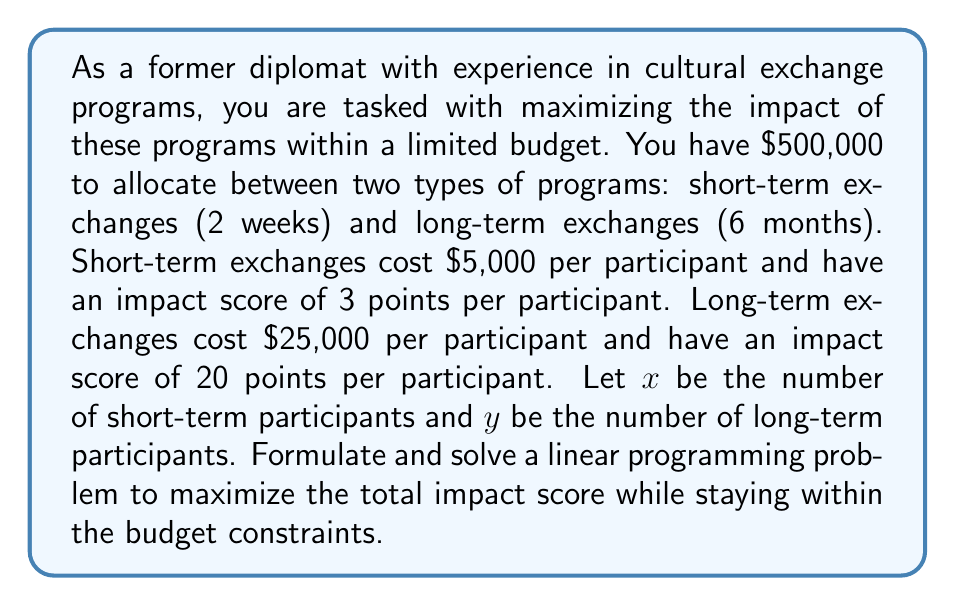Show me your answer to this math problem. To solve this linear programming problem, we'll follow these steps:

1. Define the objective function:
   We want to maximize the total impact score, which is given by:
   $$ Z = 3x + 20y $$

2. Identify the constraints:
   a) Budget constraint: $5000x + 25000y \leq 500000$
   b) Non-negativity constraints: $x \geq 0$, $y \geq 0$

3. Simplify the budget constraint:
   $$ 5x + 25y \leq 500 $$

4. Graph the feasible region:
   We'll use the budget constraint and non-negativity constraints to plot the feasible region.

5. Find the corner points of the feasible region:
   - (0, 0)
   - (100, 0)
   - (0, 20)
   - The intersection of $5x + 25y = 500$ and $x = 0$: (0, 20)
   - The intersection of $5x + 25y = 500$ and $y = 0$: (100, 0)

6. Evaluate the objective function at each corner point:
   - (0, 0): $Z = 3(0) + 20(0) = 0$
   - (100, 0): $Z = 3(100) + 20(0) = 300$
   - (0, 20): $Z = 3(0) + 20(20) = 400$

7. Choose the point that maximizes the objective function:
   The maximum value occurs at (0, 20), which corresponds to 20 long-term exchange participants and 0 short-term exchange participants.

Therefore, to maximize the impact score within the given budget constraints, the optimal solution is to send 20 participants on long-term exchanges.
Answer: The optimal solution is to allocate the entire budget to long-term exchanges, sending 20 participants for a maximum impact score of 400 points. 